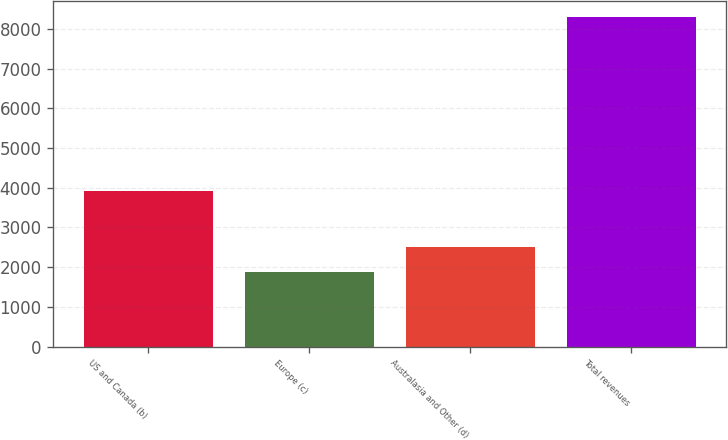Convert chart. <chart><loc_0><loc_0><loc_500><loc_500><bar_chart><fcel>US and Canada (b)<fcel>Europe (c)<fcel>Australasia and Other (d)<fcel>Total revenues<nl><fcel>3920<fcel>1873<fcel>2514.9<fcel>8292<nl></chart> 